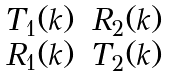<formula> <loc_0><loc_0><loc_500><loc_500>\begin{matrix} T _ { 1 } ( k ) & R _ { 2 } ( k ) \\ R _ { 1 } ( k ) & T _ { 2 } ( k ) \\ \end{matrix}</formula> 